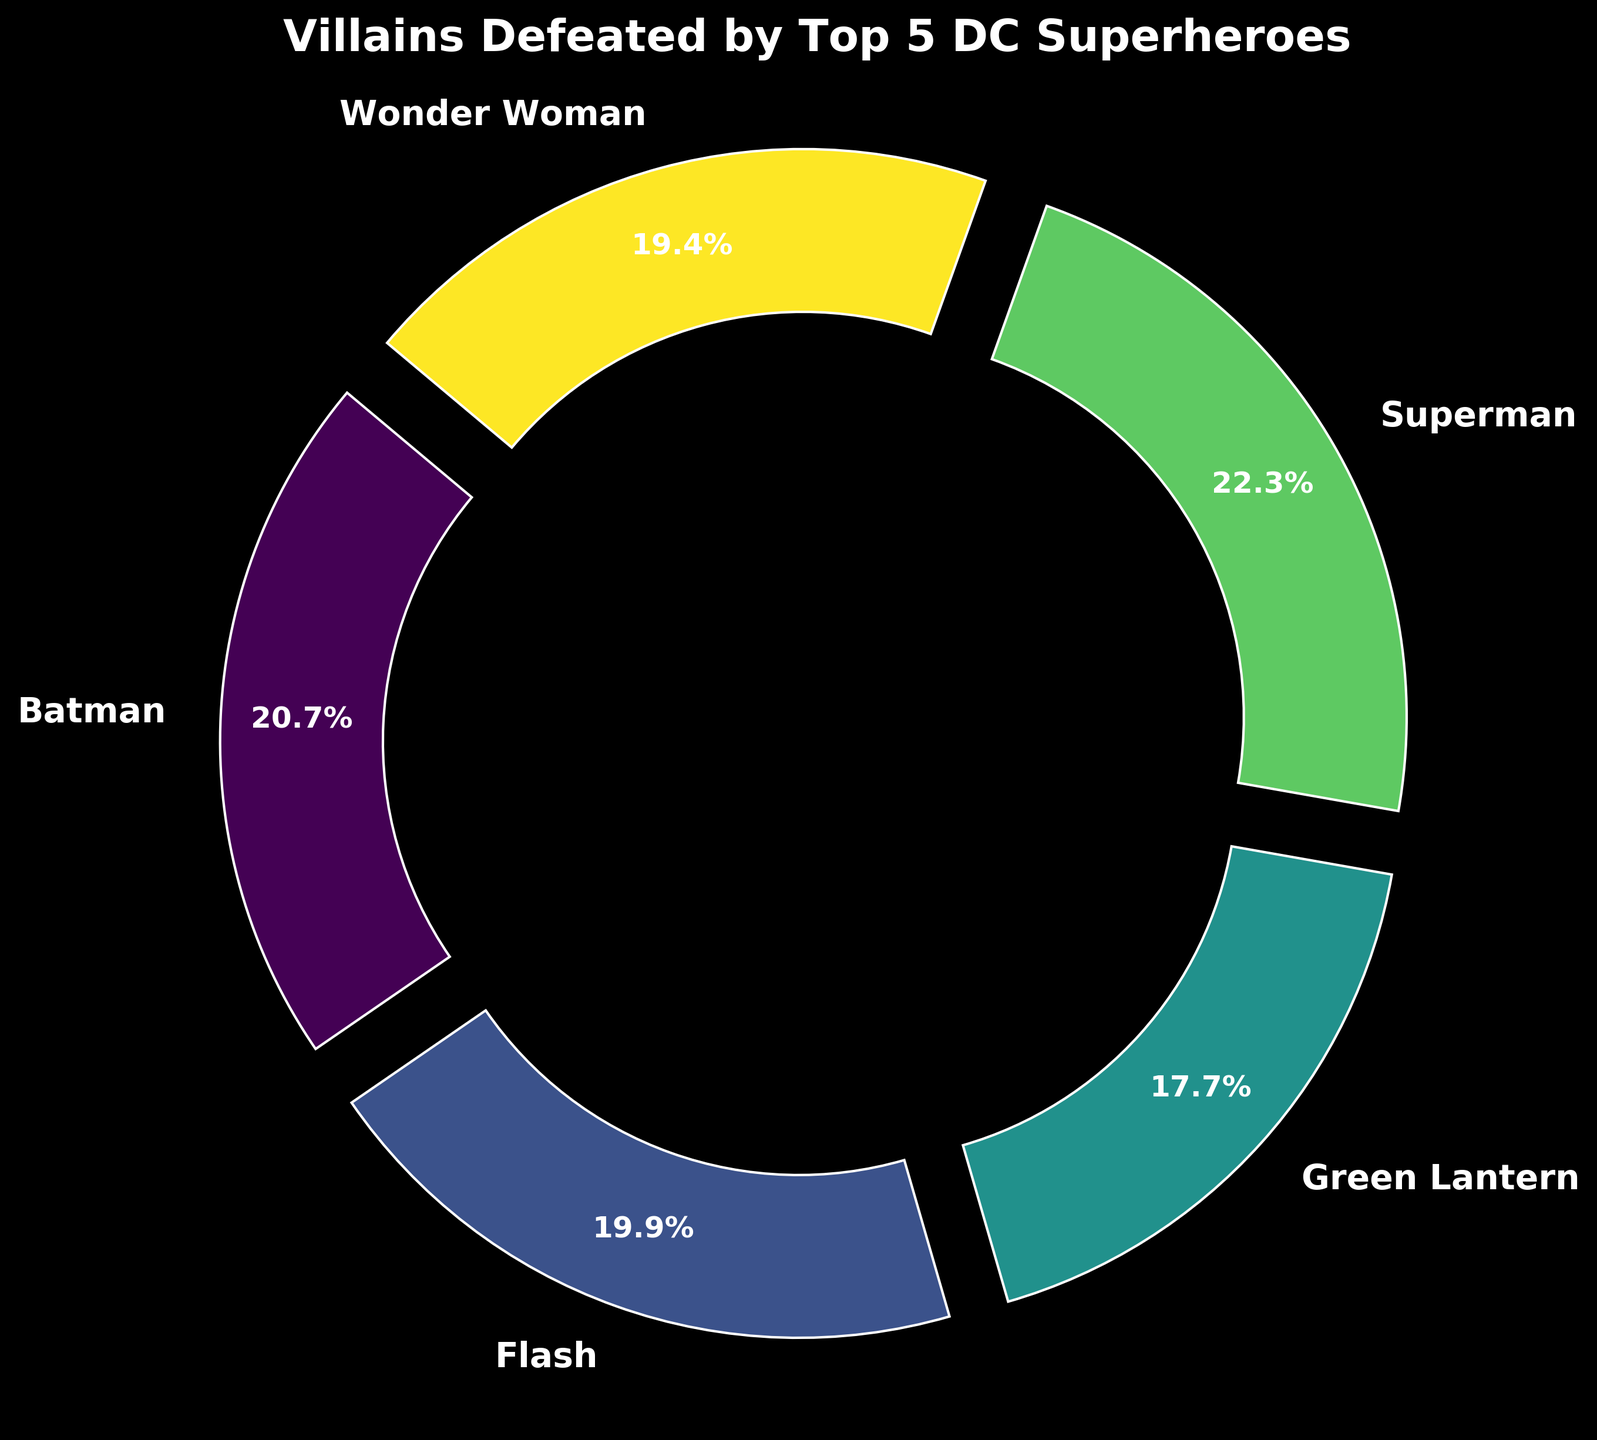What percentage of villains were defeated by Batman? Batman's section represents a specific wedge in the ring chart. By looking at the percentage label on his segment, you can determine the proportion of villains he defeated.
Answer: 29.2% Which superhero defeated the fewest number of villains? The smallest wedge in the chart corresponds to the superhero who defeated the fewest villains. By comparing the sizes and percentages, determine which wedge is the smallest.
Answer: Green Lantern What is the total number of villains defeated by all superheroes combined? To find the total, sum the number of villains defeated by each superhero. This information is needed to understand the percentages in the chart. Adding 385 (Batman) + 415 (Superman) + 360 (Wonder Woman) + 370 (Flash) + 330 (Green Lantern), we get the total.
Answer: 1860 How does the number of villains defeated by Superman compare to those defeated by Wonder Woman? Compare the percentages or visually estimate the wedge sizes for Superman and Wonder Woman. Superman's percentage is higher than Wonder Woman's, indicating a higher count.
Answer: Superman defeated more villains If Batman and Flash combined their efforts, what percentage of the total villains would they have defeated together? Add the percentages for Batman and Flash from the chart. Batman's percentage plus Flash's percentage gives their combined total. 29.2% (Batman) + 19.9% (Flash) = 49.1%.
Answer: 49.1% Who has defeated more villains: Wonder Woman or Flash? Compare the wedges or percentages associated with Wonder Woman and Flash. The superhero with the larger wedge or higher percentage has defeated more villains.
Answer: Wonder Woman What is the difference in the number of villains defeated by the top two superheroes? Identify the top two superheroes by their percentages and subtract the smaller count from the larger count. For example, if Superman and Batman are the top two with counts of 415 and 385 respectively, the difference is 415 - 385.
Answer: 30 If Green Lantern defeated 20% more villains, what would be his new percentage? Calculate 20% of Green Lantern's current count and add it to his total. Recalculate his percentage of the total combined villains. Current count: 330, 20% of 330 is 66, new count is 330+66=396. Then, 396 / 1860 * 100 = approximately 21.3%.
Answer: 21.3% Which superhero's wedge is closest in size to Superman's? Visually compare the wedges, especially focusing on those closest in size to Superman's. This gives a sense of other superheroes' efforts in defeating villains compared to Superman.
Answer: Batman 